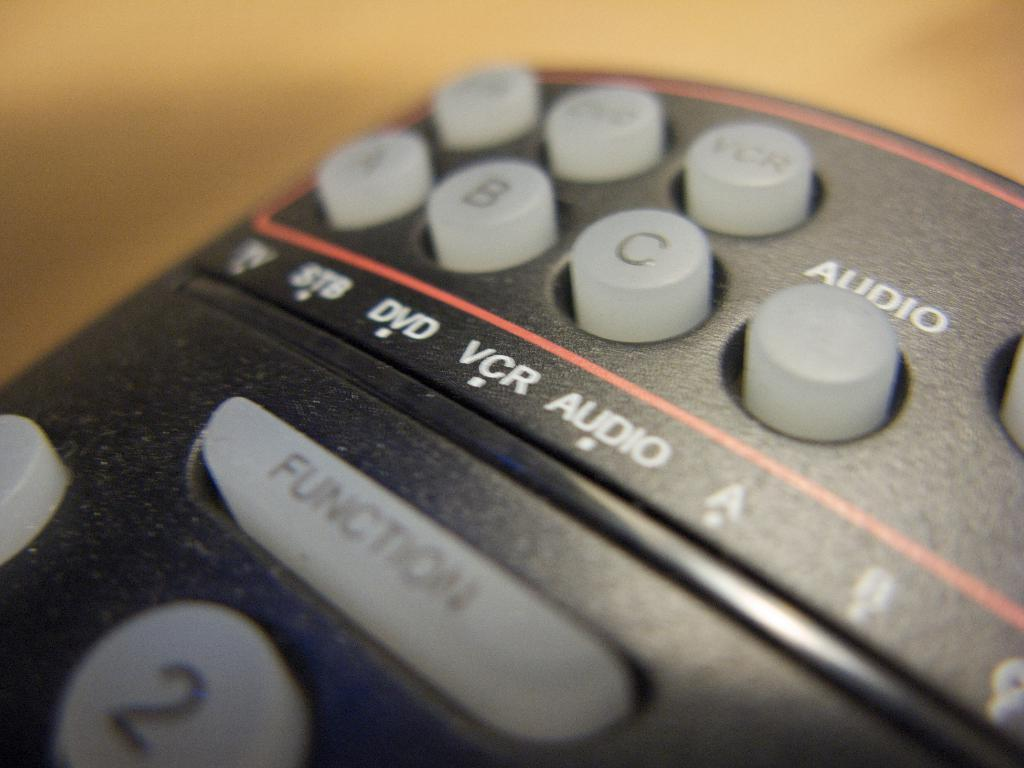Provide a one-sentence caption for the provided image. A remote control that has buttons labeled a, b, and c is laying on a counter. 